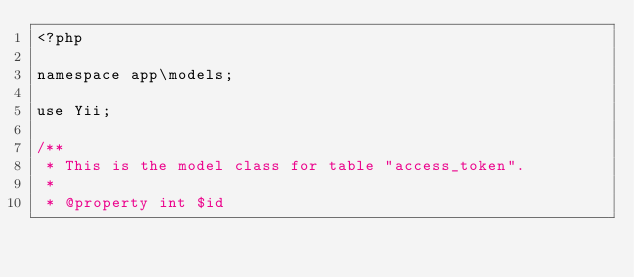<code> <loc_0><loc_0><loc_500><loc_500><_PHP_><?php

namespace app\models;

use Yii;

/**
 * This is the model class for table "access_token".
 *
 * @property int $id</code> 